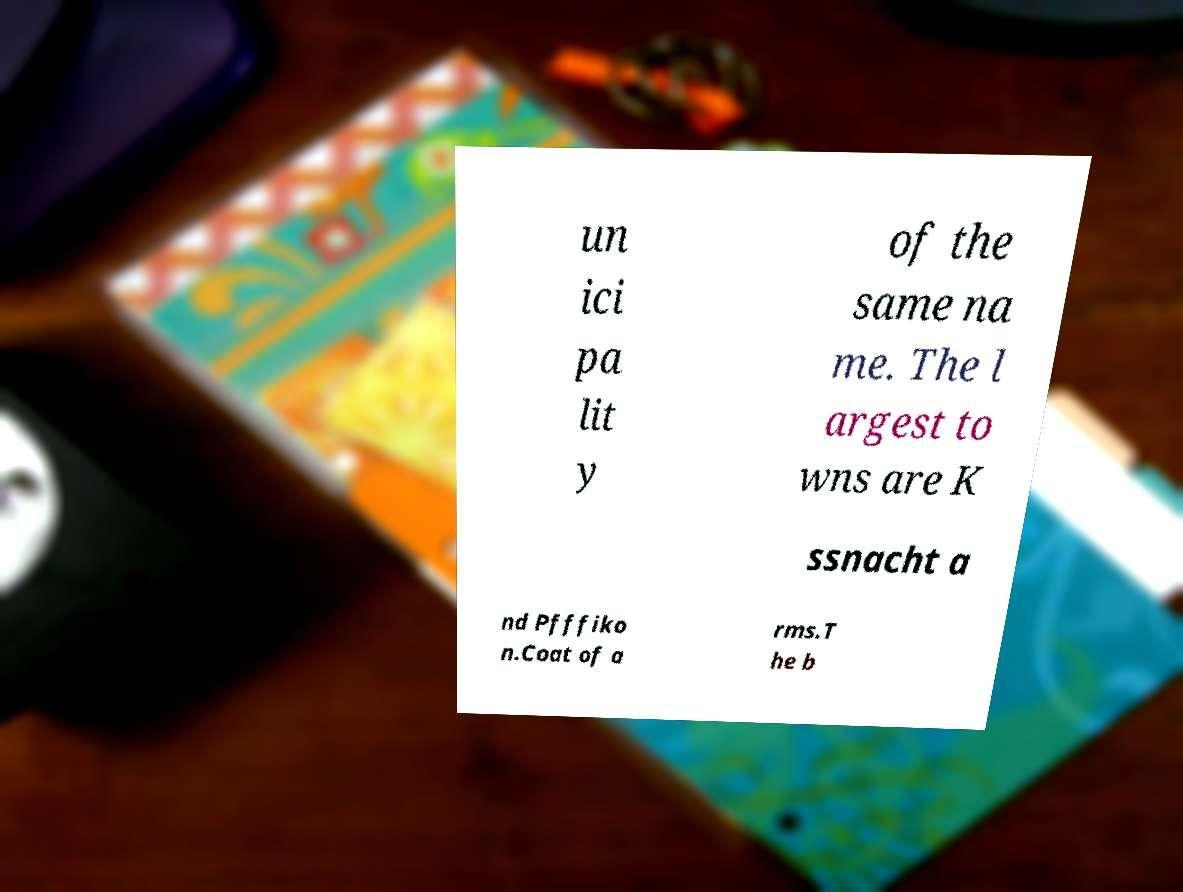Please read and relay the text visible in this image. What does it say? un ici pa lit y of the same na me. The l argest to wns are K ssnacht a nd Pfffiko n.Coat of a rms.T he b 